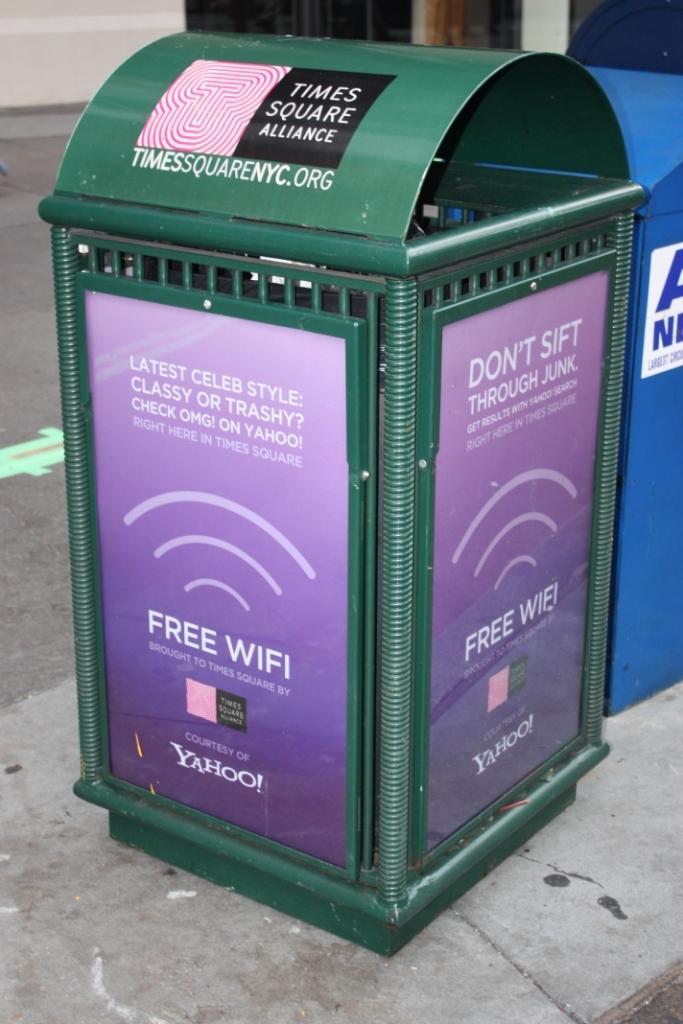<image>
Describe the image concisely. Green bin that has a purple sign saying "Free Wifi". 